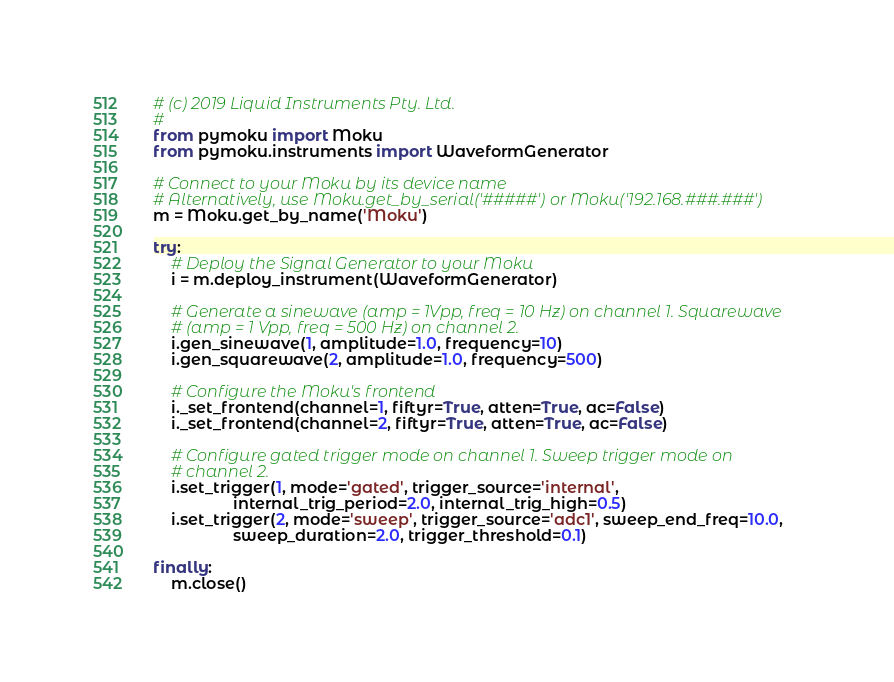<code> <loc_0><loc_0><loc_500><loc_500><_Python_># (c) 2019 Liquid Instruments Pty. Ltd.
#
from pymoku import Moku
from pymoku.instruments import WaveformGenerator

# Connect to your Moku by its device name
# Alternatively, use Moku.get_by_serial('#####') or Moku('192.168.###.###')
m = Moku.get_by_name('Moku')

try:
    # Deploy the Signal Generator to your Moku
    i = m.deploy_instrument(WaveformGenerator)

    # Generate a sinewave (amp = 1Vpp, freq = 10 Hz) on channel 1. Squarewave
    # (amp = 1 Vpp, freq = 500 Hz) on channel 2.
    i.gen_sinewave(1, amplitude=1.0, frequency=10)
    i.gen_squarewave(2, amplitude=1.0, frequency=500)

    # Configure the Moku's frontend
    i._set_frontend(channel=1, fiftyr=True, atten=True, ac=False)
    i._set_frontend(channel=2, fiftyr=True, atten=True, ac=False)

    # Configure gated trigger mode on channel 1. Sweep trigger mode on
    # channel 2.
    i.set_trigger(1, mode='gated', trigger_source='internal',
                  internal_trig_period=2.0, internal_trig_high=0.5)
    i.set_trigger(2, mode='sweep', trigger_source='adc1', sweep_end_freq=10.0,
                  sweep_duration=2.0, trigger_threshold=0.1)

finally:
    m.close()
</code> 